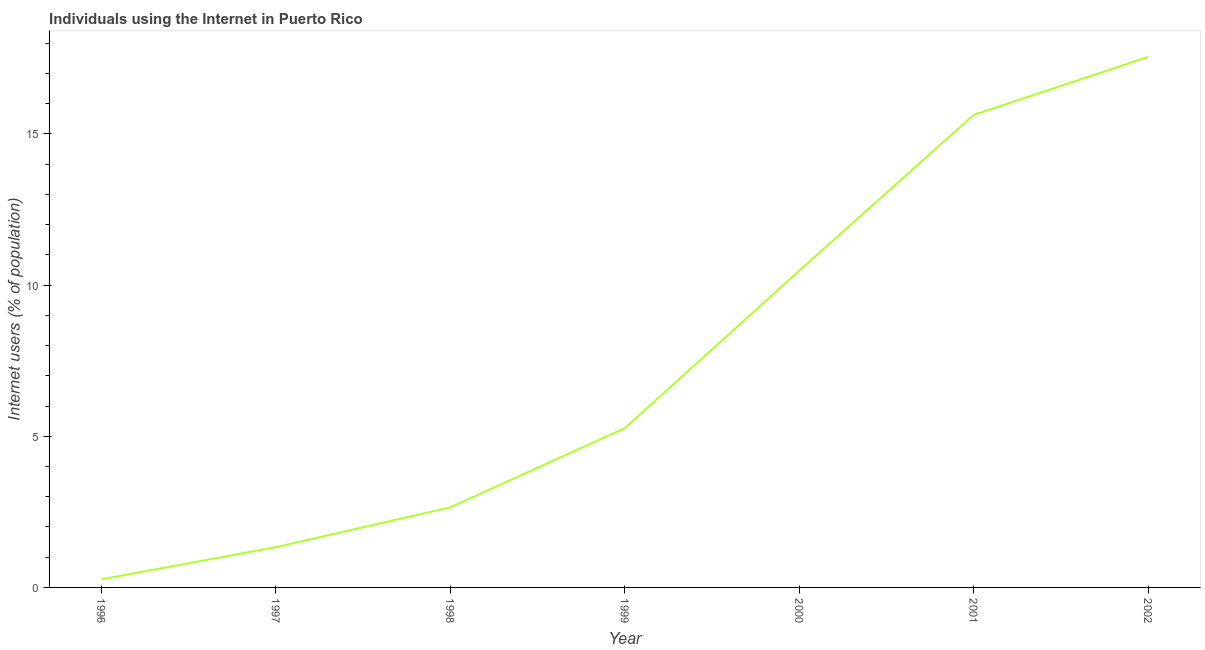What is the number of internet users in 1996?
Offer a very short reply. 0.27. Across all years, what is the maximum number of internet users?
Your answer should be compact. 17.55. Across all years, what is the minimum number of internet users?
Offer a terse response. 0.27. In which year was the number of internet users maximum?
Give a very brief answer. 2002. In which year was the number of internet users minimum?
Your answer should be very brief. 1996. What is the sum of the number of internet users?
Offer a very short reply. 53.17. What is the difference between the number of internet users in 1996 and 1998?
Give a very brief answer. -2.38. What is the average number of internet users per year?
Give a very brief answer. 7.6. What is the median number of internet users?
Your response must be concise. 5.27. What is the ratio of the number of internet users in 1998 to that in 2000?
Give a very brief answer. 0.25. What is the difference between the highest and the second highest number of internet users?
Your response must be concise. 1.92. What is the difference between the highest and the lowest number of internet users?
Provide a succinct answer. 17.28. How many lines are there?
Offer a very short reply. 1. What is the difference between two consecutive major ticks on the Y-axis?
Keep it short and to the point. 5. Does the graph contain any zero values?
Provide a succinct answer. No. What is the title of the graph?
Your answer should be very brief. Individuals using the Internet in Puerto Rico. What is the label or title of the X-axis?
Keep it short and to the point. Year. What is the label or title of the Y-axis?
Give a very brief answer. Internet users (% of population). What is the Internet users (% of population) in 1996?
Offer a terse response. 0.27. What is the Internet users (% of population) of 1997?
Make the answer very short. 1.33. What is the Internet users (% of population) in 1998?
Your answer should be very brief. 2.65. What is the Internet users (% of population) of 1999?
Your response must be concise. 5.27. What is the Internet users (% of population) of 2000?
Your answer should be compact. 10.47. What is the Internet users (% of population) of 2001?
Give a very brief answer. 15.63. What is the Internet users (% of population) of 2002?
Give a very brief answer. 17.55. What is the difference between the Internet users (% of population) in 1996 and 1997?
Your answer should be compact. -1.06. What is the difference between the Internet users (% of population) in 1996 and 1998?
Make the answer very short. -2.38. What is the difference between the Internet users (% of population) in 1996 and 1999?
Provide a succinct answer. -5. What is the difference between the Internet users (% of population) in 1996 and 2000?
Your response must be concise. -10.21. What is the difference between the Internet users (% of population) in 1996 and 2001?
Provide a succinct answer. -15.36. What is the difference between the Internet users (% of population) in 1996 and 2002?
Keep it short and to the point. -17.28. What is the difference between the Internet users (% of population) in 1997 and 1998?
Offer a very short reply. -1.32. What is the difference between the Internet users (% of population) in 1997 and 1999?
Keep it short and to the point. -3.93. What is the difference between the Internet users (% of population) in 1997 and 2000?
Give a very brief answer. -9.14. What is the difference between the Internet users (% of population) in 1997 and 2001?
Provide a short and direct response. -14.3. What is the difference between the Internet users (% of population) in 1997 and 2002?
Provide a short and direct response. -16.22. What is the difference between the Internet users (% of population) in 1998 and 1999?
Make the answer very short. -2.62. What is the difference between the Internet users (% of population) in 1998 and 2000?
Ensure brevity in your answer.  -7.83. What is the difference between the Internet users (% of population) in 1998 and 2001?
Provide a succinct answer. -12.98. What is the difference between the Internet users (% of population) in 1998 and 2002?
Offer a terse response. -14.9. What is the difference between the Internet users (% of population) in 1999 and 2000?
Provide a short and direct response. -5.21. What is the difference between the Internet users (% of population) in 1999 and 2001?
Your answer should be very brief. -10.36. What is the difference between the Internet users (% of population) in 1999 and 2002?
Offer a very short reply. -12.28. What is the difference between the Internet users (% of population) in 2000 and 2001?
Make the answer very short. -5.16. What is the difference between the Internet users (% of population) in 2000 and 2002?
Make the answer very short. -7.07. What is the difference between the Internet users (% of population) in 2001 and 2002?
Make the answer very short. -1.92. What is the ratio of the Internet users (% of population) in 1996 to that in 1997?
Your answer should be very brief. 0.2. What is the ratio of the Internet users (% of population) in 1996 to that in 1998?
Your answer should be compact. 0.1. What is the ratio of the Internet users (% of population) in 1996 to that in 1999?
Keep it short and to the point. 0.05. What is the ratio of the Internet users (% of population) in 1996 to that in 2000?
Give a very brief answer. 0.03. What is the ratio of the Internet users (% of population) in 1996 to that in 2001?
Provide a short and direct response. 0.02. What is the ratio of the Internet users (% of population) in 1996 to that in 2002?
Keep it short and to the point. 0.01. What is the ratio of the Internet users (% of population) in 1997 to that in 1998?
Offer a very short reply. 0.5. What is the ratio of the Internet users (% of population) in 1997 to that in 1999?
Provide a short and direct response. 0.25. What is the ratio of the Internet users (% of population) in 1997 to that in 2000?
Your response must be concise. 0.13. What is the ratio of the Internet users (% of population) in 1997 to that in 2001?
Ensure brevity in your answer.  0.09. What is the ratio of the Internet users (% of population) in 1997 to that in 2002?
Your response must be concise. 0.08. What is the ratio of the Internet users (% of population) in 1998 to that in 1999?
Offer a very short reply. 0.5. What is the ratio of the Internet users (% of population) in 1998 to that in 2000?
Provide a succinct answer. 0.25. What is the ratio of the Internet users (% of population) in 1998 to that in 2001?
Offer a very short reply. 0.17. What is the ratio of the Internet users (% of population) in 1998 to that in 2002?
Offer a very short reply. 0.15. What is the ratio of the Internet users (% of population) in 1999 to that in 2000?
Your answer should be compact. 0.5. What is the ratio of the Internet users (% of population) in 1999 to that in 2001?
Provide a succinct answer. 0.34. What is the ratio of the Internet users (% of population) in 2000 to that in 2001?
Give a very brief answer. 0.67. What is the ratio of the Internet users (% of population) in 2000 to that in 2002?
Offer a terse response. 0.6. What is the ratio of the Internet users (% of population) in 2001 to that in 2002?
Provide a succinct answer. 0.89. 